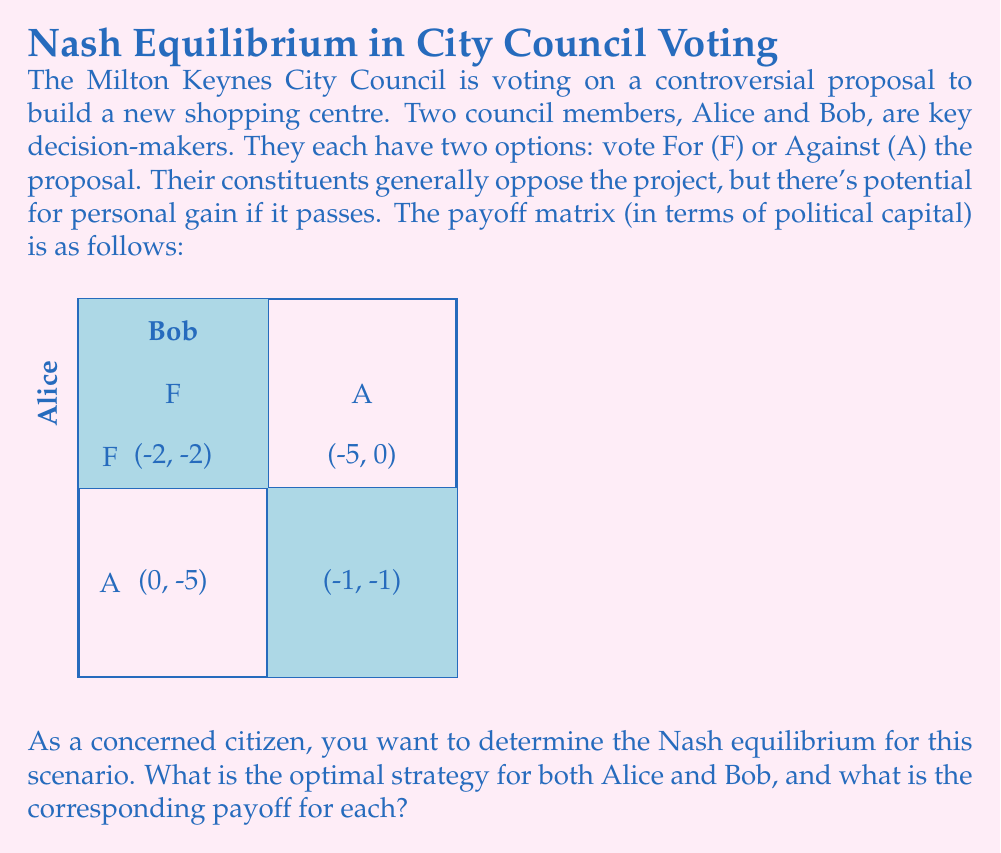Could you help me with this problem? To solve this prisoner's dilemma scenario and find the Nash equilibrium, we need to analyze each player's best response to the other's strategy:

1. Alice's perspective:
   - If Bob chooses F, Alice's best response is F (-2 > -5)
   - If Bob chooses A, Alice's best response is F (0 > -1)

2. Bob's perspective:
   - If Alice chooses F, Bob's best response is F (-2 > -5)
   - If Alice chooses A, Bob's best response is F (0 > -1)

3. Nash Equilibrium:
   The Nash equilibrium occurs when both players choose their best response to the other's strategy. In this case, regardless of what the other player does, both Alice and Bob's best strategy is to vote For (F).

4. Equilibrium outcome:
   When both Alice and Bob choose F, the payoff for each is -2.

5. Prisoner's Dilemma aspect:
   This scenario is a classic prisoner's dilemma because the Nash equilibrium (F, F) with payoffs (-2, -2) is Pareto inferior to the outcome (A, A) with payoffs (-1, -1). However, (A, A) is unstable because each player has an incentive to deviate.

6. Mathematical representation:
   Let $s_A$ and $s_B$ represent the strategies of Alice and Bob respectively, where $s_i \in \{F, A\}$.
   The Nash equilibrium $(s_A^*, s_B^*)$ satisfies:
   $$u_A(s_A^*, s_B^*) \geq u_A(s_A, s_B^*) \quad \forall s_A$$
   $$u_B(s_A^*, s_B^*) \geq u_B(s_A^*, s_B) \quad \forall s_B$$
   where $u_i$ is the utility function for player $i$.

Therefore, the Nash equilibrium is (F, F) with payoffs (-2, -2).
Answer: Nash equilibrium: (F, F); Payoffs: (-2, -2) 